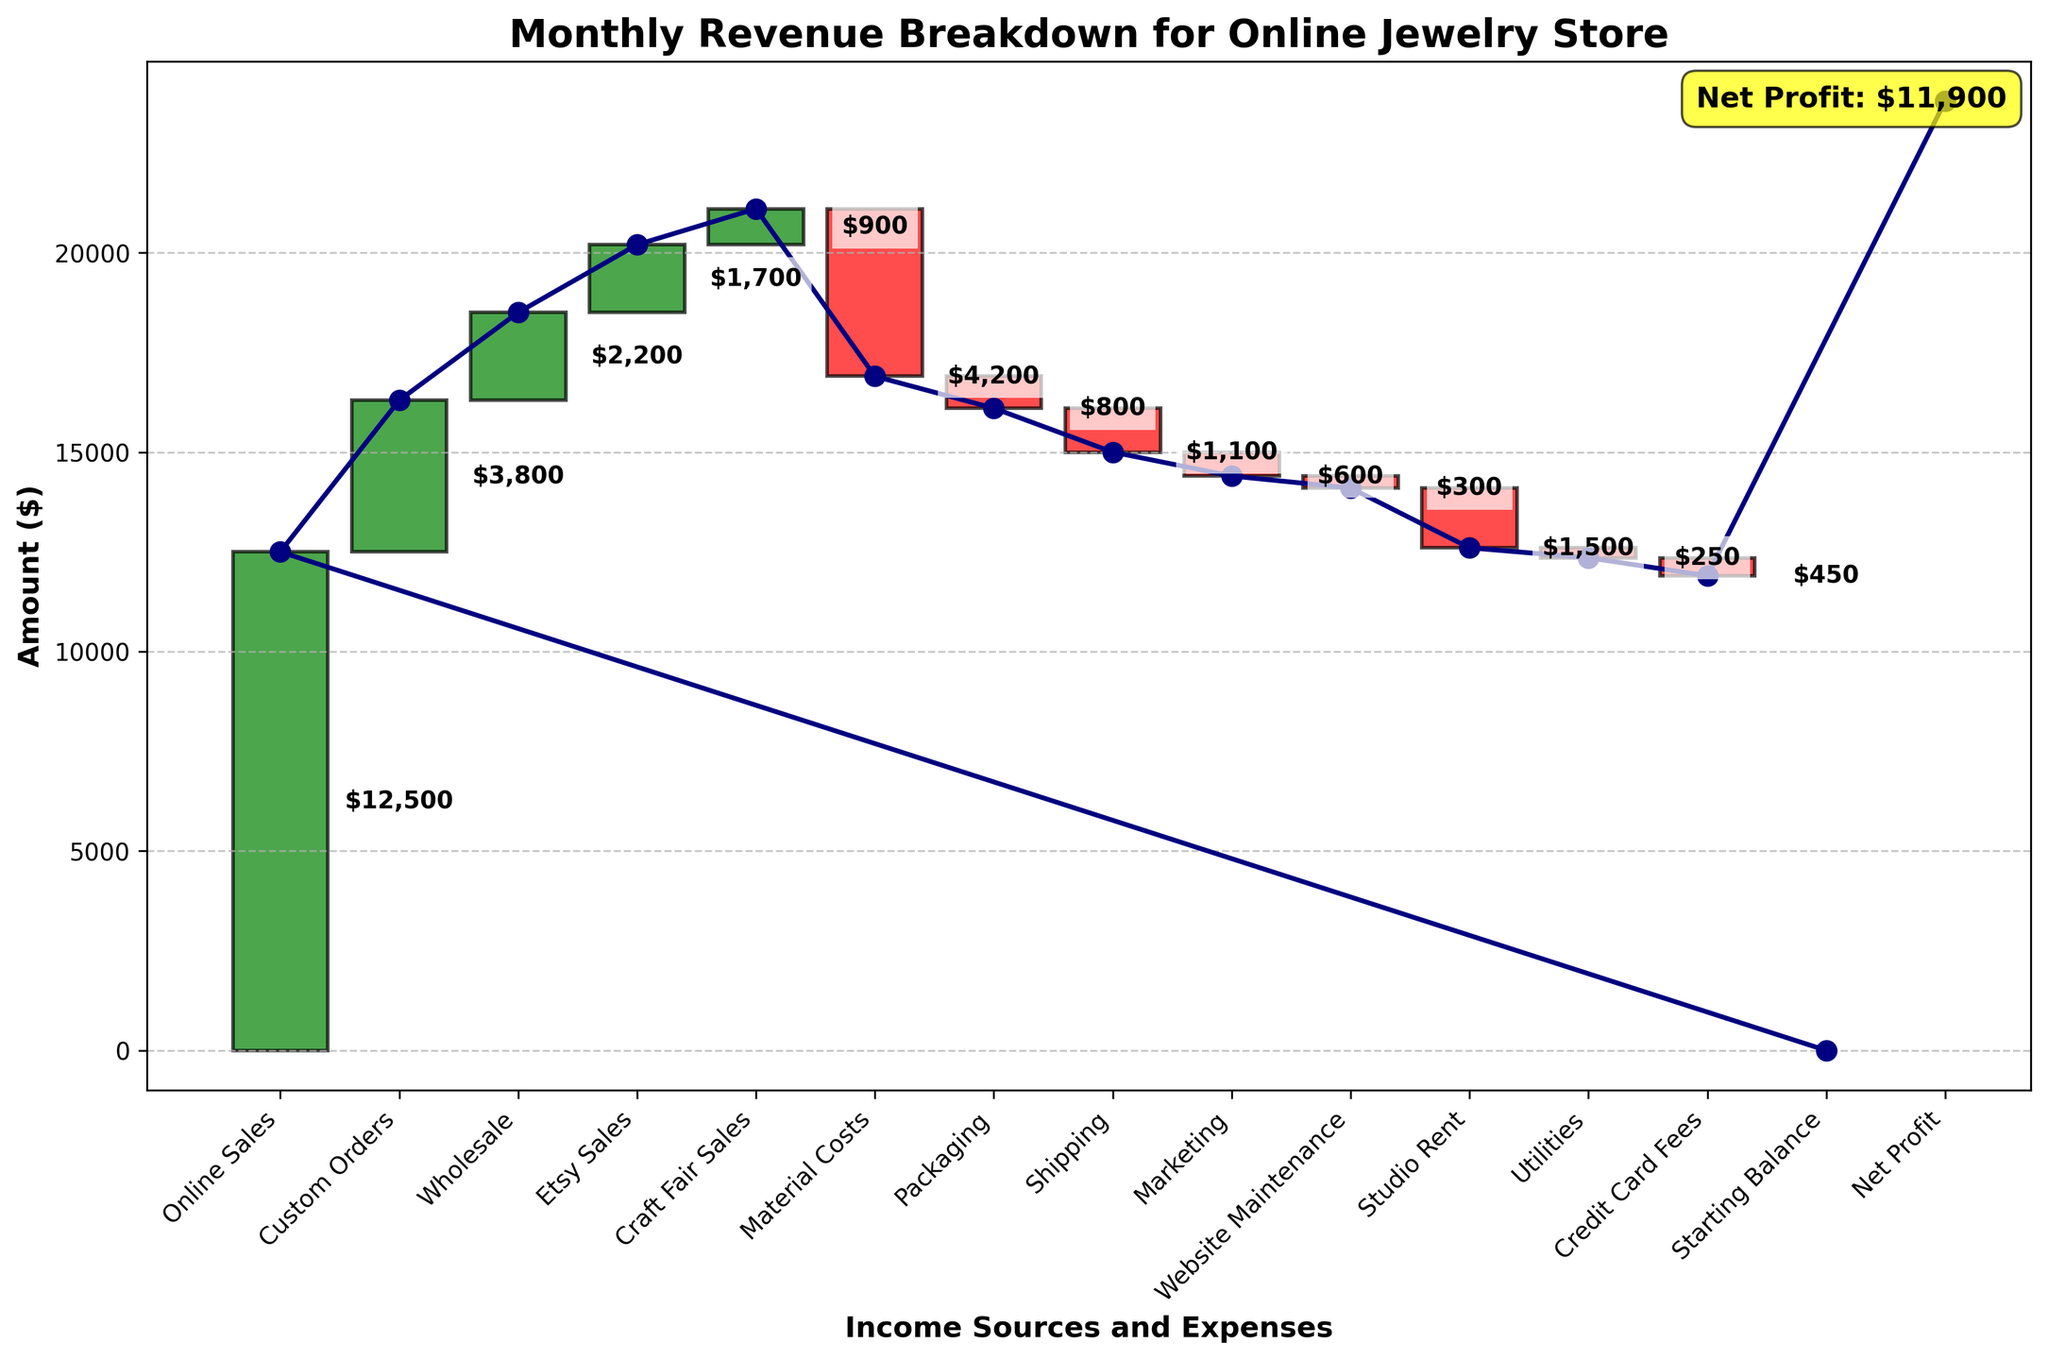What is the title of the chart? The title of the chart is prominently displayed at the top of the figure, providing context for interpreting the visual data.
Answer: Monthly Revenue Breakdown for Online Jewelry Store What are the two categories that generate the highest revenue? To find the categories with the highest revenue, look at the height of the green bars and identify the two tallest ones. These belong to "Online Sales" and "Custom Orders."
Answer: Online Sales and Custom Orders Which category has the largest expense? The largest expense will be the red bar with the greatest negative value. This is the category "Material Costs."
Answer: Material Costs How much is the net profit? The net profit is typically annotated on the plot, and in this case, it is also the last figure on the y-axis, showing the cumulative effect of all gains and expenses.
Answer: $11,900 What are the total earnings from sales categories? Add up the values of the sales categories: Online Sales ($12,500), Custom Orders ($3,800), Wholesale ($2,200), Etsy Sales ($1,700), and Craft Fair Sales ($900). The sum is $12,500 + $3,800 + $2,200 + $1,700 + $900.
Answer: $21,100 What is the combined cost of packaging and shipping? Sum the values for Packaging and Shipping: -$800 (Packaging) + -$1,100 (Shipping).
Answer: -$1,900 Which expense is greater, studio rent or credit card fees? Compare the heights of the red bars for "Studio Rent" (-$1,500) and "Credit Card Fees" (-$450).
Answer: Studio Rent How do marketing expenses compare to website maintenance costs? Compare the heights of the red bars for "Marketing" (-$600) and "Website Maintenance" (-$300).
Answer: Marketing expenses are higher What is the height of the starting balance? The starting balance typically begins the waterfall chart, and it is usually zero, marking the baseline for other categories.
Answer: $0 Which category is at the second position from the left, and what is its value? The second category from the left after the starting balance is "Online Sales," with a value indicated by the bar and label.
Answer: Online Sales, $12,500 